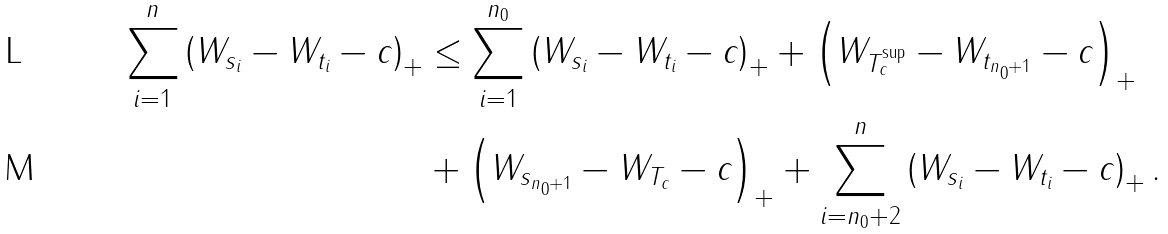Convert formula to latex. <formula><loc_0><loc_0><loc_500><loc_500>\sum _ { i = 1 } ^ { n } \left ( W _ { s _ { i } } - W _ { t _ { i } } - c \right ) _ { + } & \leq \sum _ { i = 1 } ^ { n _ { 0 } } \left ( W _ { s _ { i } } - W _ { t _ { i } } - c \right ) _ { + } + \left ( W _ { T _ { c } ^ { \sup } } - W _ { t _ { n _ { 0 } + 1 } } - c \right ) _ { + } \\ & + \left ( W _ { s _ { n _ { 0 } + 1 } } - W _ { T _ { c } } - c \right ) _ { + } + \sum _ { i = n _ { 0 } + 2 } ^ { n } \left ( W _ { s _ { i } } - W _ { t _ { i } } - c \right ) _ { + } .</formula> 